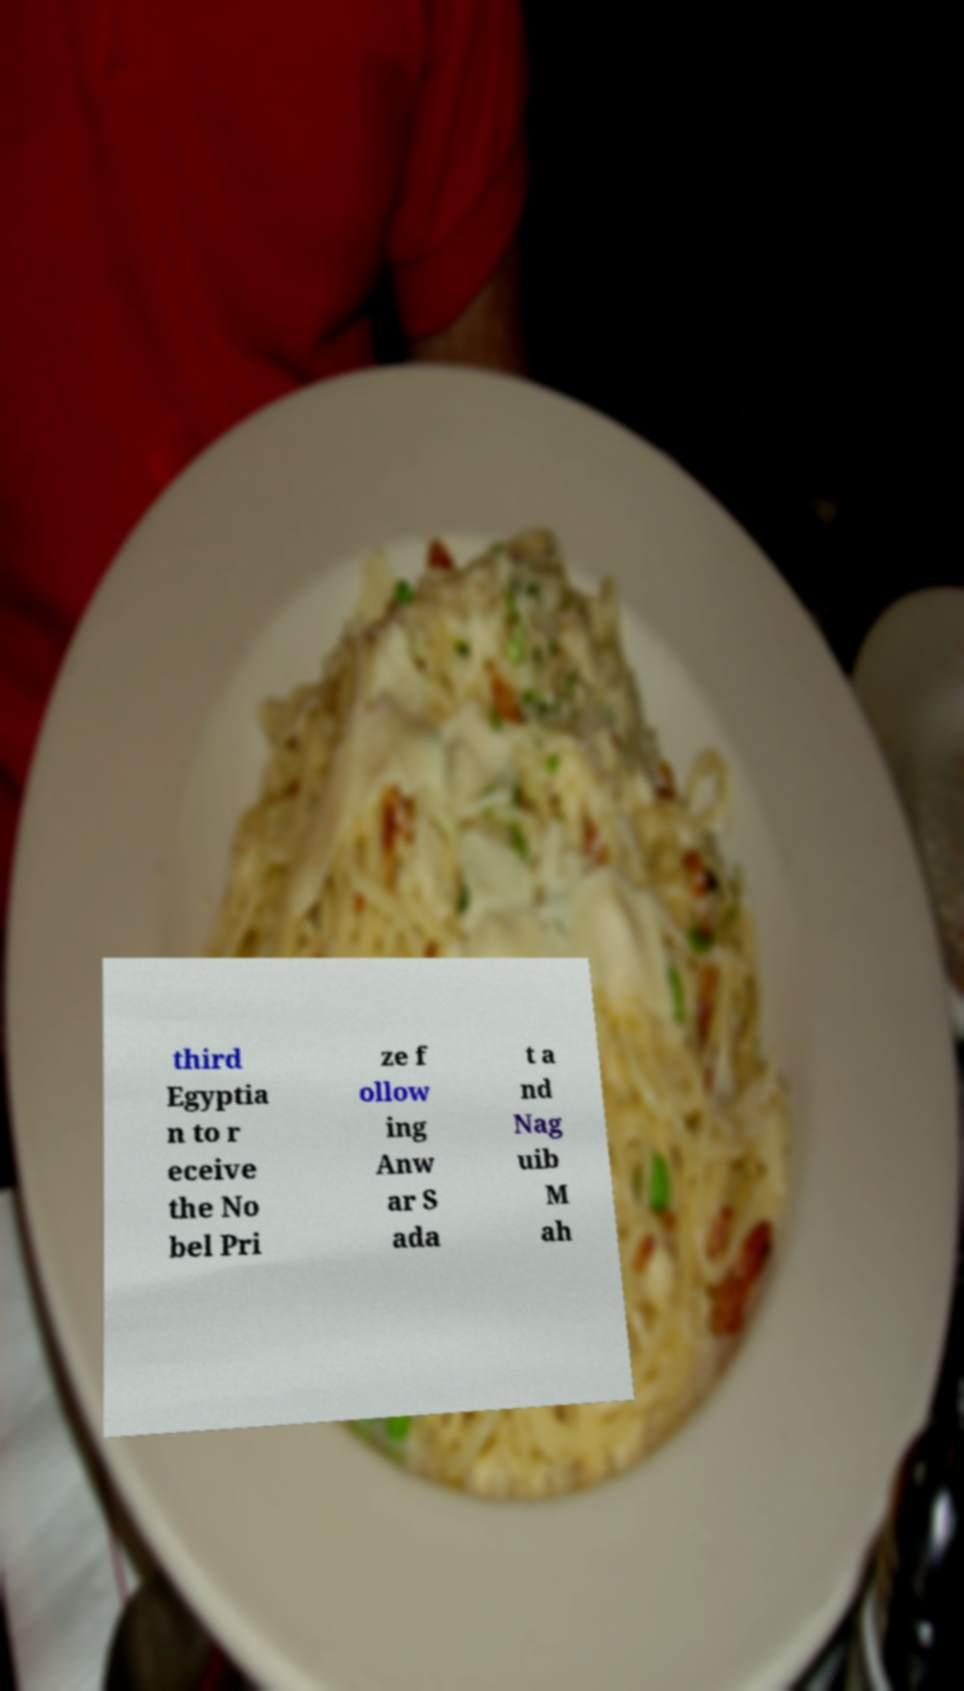Please read and relay the text visible in this image. What does it say? third Egyptia n to r eceive the No bel Pri ze f ollow ing Anw ar S ada t a nd Nag uib M ah 